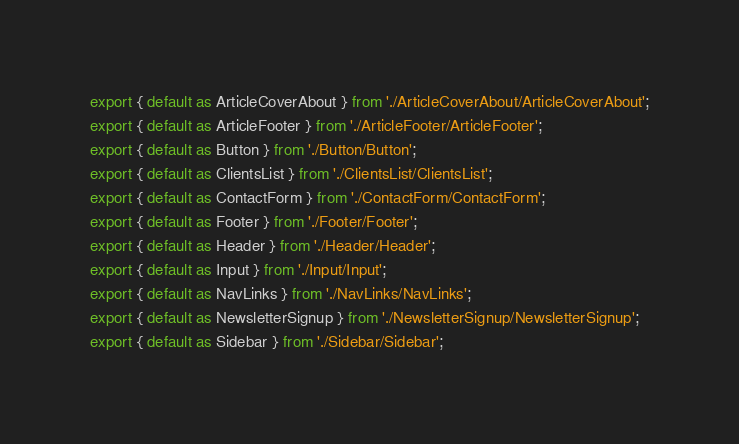Convert code to text. <code><loc_0><loc_0><loc_500><loc_500><_JavaScript_>export { default as ArticleCoverAbout } from './ArticleCoverAbout/ArticleCoverAbout';
export { default as ArticleFooter } from './ArticleFooter/ArticleFooter';
export { default as Button } from './Button/Button';
export { default as ClientsList } from './ClientsList/ClientsList';
export { default as ContactForm } from './ContactForm/ContactForm';
export { default as Footer } from './Footer/Footer';
export { default as Header } from './Header/Header';
export { default as Input } from './Input/Input';
export { default as NavLinks } from './NavLinks/NavLinks';
export { default as NewsletterSignup } from './NewsletterSignup/NewsletterSignup';
export { default as Sidebar } from './Sidebar/Sidebar';
</code> 